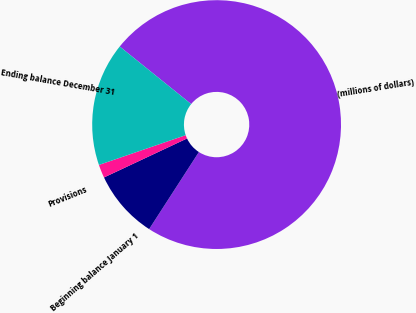Convert chart to OTSL. <chart><loc_0><loc_0><loc_500><loc_500><pie_chart><fcel>(millions of dollars)<fcel>Beginning balance January 1<fcel>Provisions<fcel>Ending balance December 31<nl><fcel>73.33%<fcel>8.89%<fcel>1.73%<fcel>16.05%<nl></chart> 